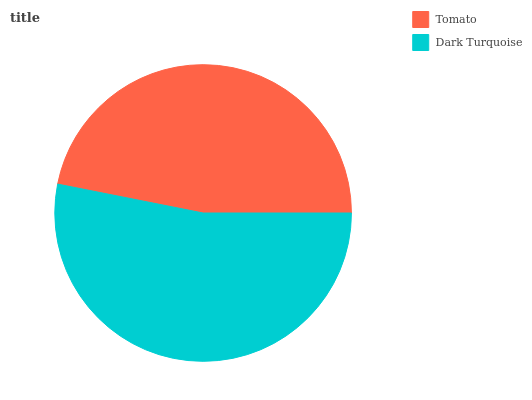Is Tomato the minimum?
Answer yes or no. Yes. Is Dark Turquoise the maximum?
Answer yes or no. Yes. Is Dark Turquoise the minimum?
Answer yes or no. No. Is Dark Turquoise greater than Tomato?
Answer yes or no. Yes. Is Tomato less than Dark Turquoise?
Answer yes or no. Yes. Is Tomato greater than Dark Turquoise?
Answer yes or no. No. Is Dark Turquoise less than Tomato?
Answer yes or no. No. Is Dark Turquoise the high median?
Answer yes or no. Yes. Is Tomato the low median?
Answer yes or no. Yes. Is Tomato the high median?
Answer yes or no. No. Is Dark Turquoise the low median?
Answer yes or no. No. 